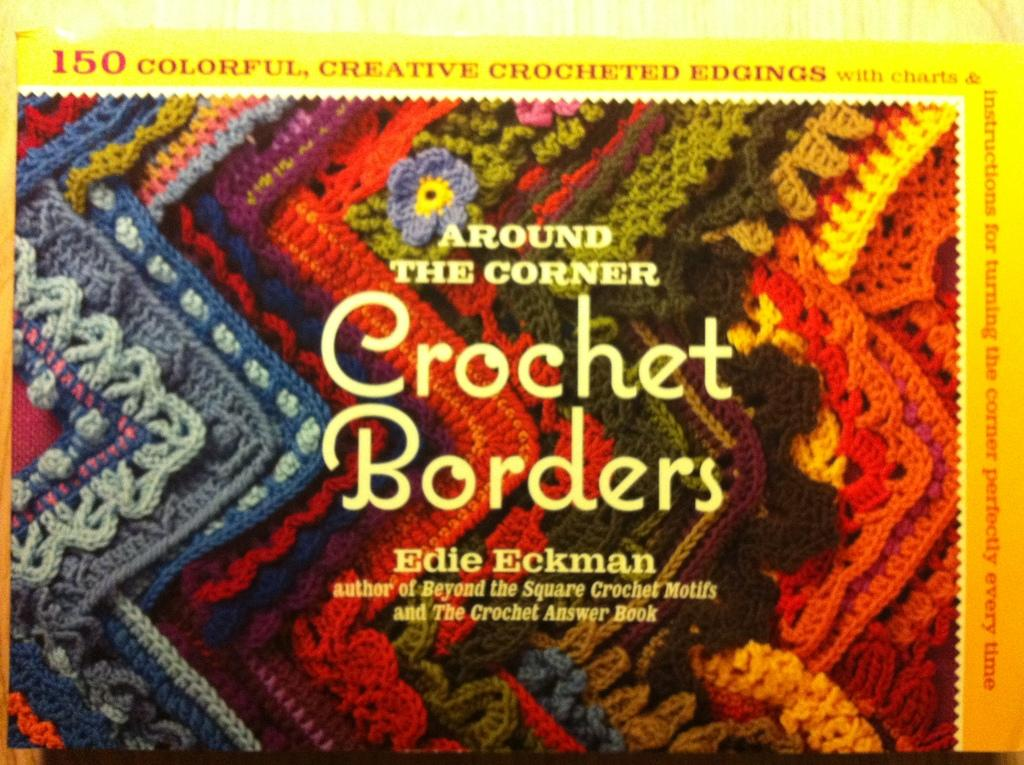<image>
Describe the image concisely. The cover page of Around the Corner Crochet Borders by Edie Eckman showing brightly coloured crochet borders. 